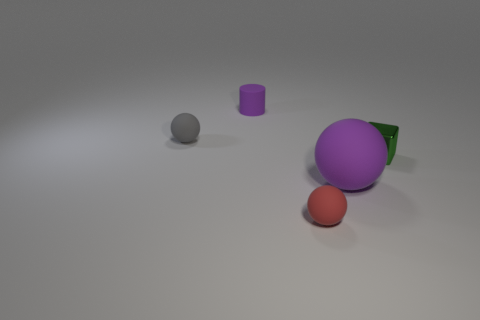Add 2 big gray blocks. How many objects exist? 7 Subtract all cubes. How many objects are left? 4 Add 4 tiny matte cylinders. How many tiny matte cylinders are left? 5 Add 4 purple matte things. How many purple matte things exist? 6 Subtract 0 brown spheres. How many objects are left? 5 Subtract all tiny red balls. Subtract all purple shiny things. How many objects are left? 4 